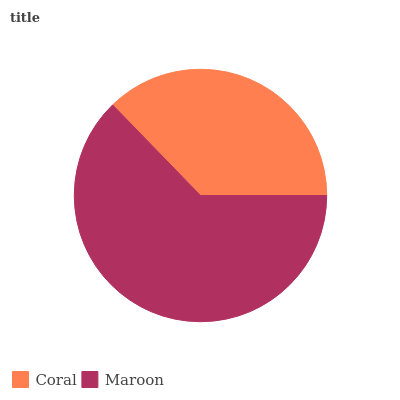Is Coral the minimum?
Answer yes or no. Yes. Is Maroon the maximum?
Answer yes or no. Yes. Is Maroon the minimum?
Answer yes or no. No. Is Maroon greater than Coral?
Answer yes or no. Yes. Is Coral less than Maroon?
Answer yes or no. Yes. Is Coral greater than Maroon?
Answer yes or no. No. Is Maroon less than Coral?
Answer yes or no. No. Is Maroon the high median?
Answer yes or no. Yes. Is Coral the low median?
Answer yes or no. Yes. Is Coral the high median?
Answer yes or no. No. Is Maroon the low median?
Answer yes or no. No. 